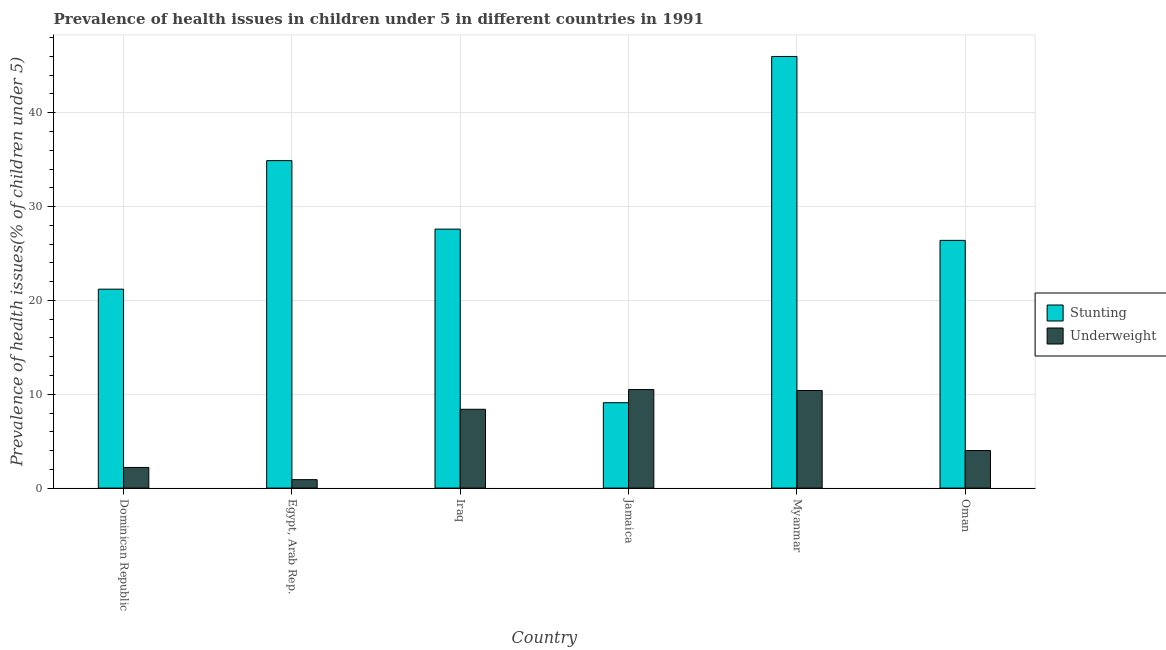How many groups of bars are there?
Make the answer very short. 6. What is the label of the 6th group of bars from the left?
Keep it short and to the point. Oman. What is the percentage of underweight children in Jamaica?
Offer a terse response. 10.5. Across all countries, what is the minimum percentage of stunted children?
Make the answer very short. 9.1. In which country was the percentage of stunted children maximum?
Provide a succinct answer. Myanmar. In which country was the percentage of stunted children minimum?
Provide a short and direct response. Jamaica. What is the total percentage of stunted children in the graph?
Offer a terse response. 165.2. What is the difference between the percentage of stunted children in Jamaica and that in Oman?
Ensure brevity in your answer.  -17.3. What is the difference between the percentage of underweight children in Oman and the percentage of stunted children in Jamaica?
Ensure brevity in your answer.  -5.1. What is the average percentage of stunted children per country?
Your response must be concise. 27.53. What is the difference between the percentage of underweight children and percentage of stunted children in Myanmar?
Ensure brevity in your answer.  -35.6. In how many countries, is the percentage of stunted children greater than 28 %?
Ensure brevity in your answer.  2. What is the ratio of the percentage of underweight children in Iraq to that in Oman?
Your answer should be very brief. 2.1. Is the percentage of stunted children in Jamaica less than that in Myanmar?
Provide a short and direct response. Yes. Is the difference between the percentage of underweight children in Dominican Republic and Jamaica greater than the difference between the percentage of stunted children in Dominican Republic and Jamaica?
Keep it short and to the point. No. What is the difference between the highest and the second highest percentage of stunted children?
Provide a succinct answer. 11.1. What is the difference between the highest and the lowest percentage of stunted children?
Ensure brevity in your answer.  36.9. Is the sum of the percentage of stunted children in Egypt, Arab Rep. and Myanmar greater than the maximum percentage of underweight children across all countries?
Make the answer very short. Yes. What does the 1st bar from the left in Jamaica represents?
Keep it short and to the point. Stunting. What does the 1st bar from the right in Jamaica represents?
Provide a short and direct response. Underweight. How many bars are there?
Make the answer very short. 12. How many countries are there in the graph?
Your response must be concise. 6. Are the values on the major ticks of Y-axis written in scientific E-notation?
Your response must be concise. No. Does the graph contain any zero values?
Your answer should be very brief. No. How are the legend labels stacked?
Your answer should be compact. Vertical. What is the title of the graph?
Keep it short and to the point. Prevalence of health issues in children under 5 in different countries in 1991. What is the label or title of the Y-axis?
Offer a terse response. Prevalence of health issues(% of children under 5). What is the Prevalence of health issues(% of children under 5) in Stunting in Dominican Republic?
Keep it short and to the point. 21.2. What is the Prevalence of health issues(% of children under 5) of Underweight in Dominican Republic?
Offer a terse response. 2.2. What is the Prevalence of health issues(% of children under 5) in Stunting in Egypt, Arab Rep.?
Your response must be concise. 34.9. What is the Prevalence of health issues(% of children under 5) of Underweight in Egypt, Arab Rep.?
Make the answer very short. 0.9. What is the Prevalence of health issues(% of children under 5) of Stunting in Iraq?
Your answer should be very brief. 27.6. What is the Prevalence of health issues(% of children under 5) in Underweight in Iraq?
Your answer should be very brief. 8.4. What is the Prevalence of health issues(% of children under 5) in Stunting in Jamaica?
Give a very brief answer. 9.1. What is the Prevalence of health issues(% of children under 5) of Underweight in Jamaica?
Make the answer very short. 10.5. What is the Prevalence of health issues(% of children under 5) of Stunting in Myanmar?
Offer a very short reply. 46. What is the Prevalence of health issues(% of children under 5) in Underweight in Myanmar?
Offer a very short reply. 10.4. What is the Prevalence of health issues(% of children under 5) of Stunting in Oman?
Keep it short and to the point. 26.4. Across all countries, what is the maximum Prevalence of health issues(% of children under 5) in Underweight?
Offer a very short reply. 10.5. Across all countries, what is the minimum Prevalence of health issues(% of children under 5) in Stunting?
Provide a succinct answer. 9.1. Across all countries, what is the minimum Prevalence of health issues(% of children under 5) of Underweight?
Ensure brevity in your answer.  0.9. What is the total Prevalence of health issues(% of children under 5) in Stunting in the graph?
Your answer should be very brief. 165.2. What is the total Prevalence of health issues(% of children under 5) in Underweight in the graph?
Your answer should be very brief. 36.4. What is the difference between the Prevalence of health issues(% of children under 5) of Stunting in Dominican Republic and that in Egypt, Arab Rep.?
Your answer should be compact. -13.7. What is the difference between the Prevalence of health issues(% of children under 5) of Underweight in Dominican Republic and that in Egypt, Arab Rep.?
Keep it short and to the point. 1.3. What is the difference between the Prevalence of health issues(% of children under 5) in Stunting in Dominican Republic and that in Iraq?
Offer a terse response. -6.4. What is the difference between the Prevalence of health issues(% of children under 5) of Underweight in Dominican Republic and that in Jamaica?
Offer a terse response. -8.3. What is the difference between the Prevalence of health issues(% of children under 5) of Stunting in Dominican Republic and that in Myanmar?
Provide a succinct answer. -24.8. What is the difference between the Prevalence of health issues(% of children under 5) in Underweight in Dominican Republic and that in Myanmar?
Provide a short and direct response. -8.2. What is the difference between the Prevalence of health issues(% of children under 5) in Stunting in Dominican Republic and that in Oman?
Offer a terse response. -5.2. What is the difference between the Prevalence of health issues(% of children under 5) of Underweight in Dominican Republic and that in Oman?
Make the answer very short. -1.8. What is the difference between the Prevalence of health issues(% of children under 5) in Underweight in Egypt, Arab Rep. and that in Iraq?
Give a very brief answer. -7.5. What is the difference between the Prevalence of health issues(% of children under 5) of Stunting in Egypt, Arab Rep. and that in Jamaica?
Provide a succinct answer. 25.8. What is the difference between the Prevalence of health issues(% of children under 5) in Underweight in Egypt, Arab Rep. and that in Jamaica?
Your answer should be very brief. -9.6. What is the difference between the Prevalence of health issues(% of children under 5) in Stunting in Egypt, Arab Rep. and that in Myanmar?
Provide a succinct answer. -11.1. What is the difference between the Prevalence of health issues(% of children under 5) of Stunting in Iraq and that in Jamaica?
Your answer should be very brief. 18.5. What is the difference between the Prevalence of health issues(% of children under 5) of Underweight in Iraq and that in Jamaica?
Your answer should be very brief. -2.1. What is the difference between the Prevalence of health issues(% of children under 5) in Stunting in Iraq and that in Myanmar?
Keep it short and to the point. -18.4. What is the difference between the Prevalence of health issues(% of children under 5) in Stunting in Iraq and that in Oman?
Make the answer very short. 1.2. What is the difference between the Prevalence of health issues(% of children under 5) in Underweight in Iraq and that in Oman?
Keep it short and to the point. 4.4. What is the difference between the Prevalence of health issues(% of children under 5) of Stunting in Jamaica and that in Myanmar?
Offer a very short reply. -36.9. What is the difference between the Prevalence of health issues(% of children under 5) of Stunting in Jamaica and that in Oman?
Offer a very short reply. -17.3. What is the difference between the Prevalence of health issues(% of children under 5) of Underweight in Jamaica and that in Oman?
Give a very brief answer. 6.5. What is the difference between the Prevalence of health issues(% of children under 5) in Stunting in Myanmar and that in Oman?
Make the answer very short. 19.6. What is the difference between the Prevalence of health issues(% of children under 5) of Stunting in Dominican Republic and the Prevalence of health issues(% of children under 5) of Underweight in Egypt, Arab Rep.?
Ensure brevity in your answer.  20.3. What is the difference between the Prevalence of health issues(% of children under 5) in Stunting in Dominican Republic and the Prevalence of health issues(% of children under 5) in Underweight in Jamaica?
Offer a terse response. 10.7. What is the difference between the Prevalence of health issues(% of children under 5) of Stunting in Dominican Republic and the Prevalence of health issues(% of children under 5) of Underweight in Myanmar?
Keep it short and to the point. 10.8. What is the difference between the Prevalence of health issues(% of children under 5) in Stunting in Dominican Republic and the Prevalence of health issues(% of children under 5) in Underweight in Oman?
Keep it short and to the point. 17.2. What is the difference between the Prevalence of health issues(% of children under 5) of Stunting in Egypt, Arab Rep. and the Prevalence of health issues(% of children under 5) of Underweight in Jamaica?
Make the answer very short. 24.4. What is the difference between the Prevalence of health issues(% of children under 5) in Stunting in Egypt, Arab Rep. and the Prevalence of health issues(% of children under 5) in Underweight in Oman?
Provide a short and direct response. 30.9. What is the difference between the Prevalence of health issues(% of children under 5) of Stunting in Iraq and the Prevalence of health issues(% of children under 5) of Underweight in Myanmar?
Provide a succinct answer. 17.2. What is the difference between the Prevalence of health issues(% of children under 5) of Stunting in Iraq and the Prevalence of health issues(% of children under 5) of Underweight in Oman?
Make the answer very short. 23.6. What is the difference between the Prevalence of health issues(% of children under 5) in Stunting in Jamaica and the Prevalence of health issues(% of children under 5) in Underweight in Myanmar?
Offer a terse response. -1.3. What is the average Prevalence of health issues(% of children under 5) in Stunting per country?
Provide a succinct answer. 27.53. What is the average Prevalence of health issues(% of children under 5) in Underweight per country?
Offer a very short reply. 6.07. What is the difference between the Prevalence of health issues(% of children under 5) of Stunting and Prevalence of health issues(% of children under 5) of Underweight in Egypt, Arab Rep.?
Your answer should be very brief. 34. What is the difference between the Prevalence of health issues(% of children under 5) of Stunting and Prevalence of health issues(% of children under 5) of Underweight in Iraq?
Offer a terse response. 19.2. What is the difference between the Prevalence of health issues(% of children under 5) of Stunting and Prevalence of health issues(% of children under 5) of Underweight in Myanmar?
Keep it short and to the point. 35.6. What is the difference between the Prevalence of health issues(% of children under 5) of Stunting and Prevalence of health issues(% of children under 5) of Underweight in Oman?
Ensure brevity in your answer.  22.4. What is the ratio of the Prevalence of health issues(% of children under 5) of Stunting in Dominican Republic to that in Egypt, Arab Rep.?
Your response must be concise. 0.61. What is the ratio of the Prevalence of health issues(% of children under 5) in Underweight in Dominican Republic to that in Egypt, Arab Rep.?
Make the answer very short. 2.44. What is the ratio of the Prevalence of health issues(% of children under 5) of Stunting in Dominican Republic to that in Iraq?
Ensure brevity in your answer.  0.77. What is the ratio of the Prevalence of health issues(% of children under 5) in Underweight in Dominican Republic to that in Iraq?
Provide a succinct answer. 0.26. What is the ratio of the Prevalence of health issues(% of children under 5) in Stunting in Dominican Republic to that in Jamaica?
Make the answer very short. 2.33. What is the ratio of the Prevalence of health issues(% of children under 5) of Underweight in Dominican Republic to that in Jamaica?
Ensure brevity in your answer.  0.21. What is the ratio of the Prevalence of health issues(% of children under 5) in Stunting in Dominican Republic to that in Myanmar?
Offer a very short reply. 0.46. What is the ratio of the Prevalence of health issues(% of children under 5) of Underweight in Dominican Republic to that in Myanmar?
Ensure brevity in your answer.  0.21. What is the ratio of the Prevalence of health issues(% of children under 5) in Stunting in Dominican Republic to that in Oman?
Offer a very short reply. 0.8. What is the ratio of the Prevalence of health issues(% of children under 5) in Underweight in Dominican Republic to that in Oman?
Ensure brevity in your answer.  0.55. What is the ratio of the Prevalence of health issues(% of children under 5) in Stunting in Egypt, Arab Rep. to that in Iraq?
Your response must be concise. 1.26. What is the ratio of the Prevalence of health issues(% of children under 5) of Underweight in Egypt, Arab Rep. to that in Iraq?
Make the answer very short. 0.11. What is the ratio of the Prevalence of health issues(% of children under 5) in Stunting in Egypt, Arab Rep. to that in Jamaica?
Give a very brief answer. 3.84. What is the ratio of the Prevalence of health issues(% of children under 5) of Underweight in Egypt, Arab Rep. to that in Jamaica?
Your response must be concise. 0.09. What is the ratio of the Prevalence of health issues(% of children under 5) of Stunting in Egypt, Arab Rep. to that in Myanmar?
Your answer should be very brief. 0.76. What is the ratio of the Prevalence of health issues(% of children under 5) in Underweight in Egypt, Arab Rep. to that in Myanmar?
Your answer should be compact. 0.09. What is the ratio of the Prevalence of health issues(% of children under 5) of Stunting in Egypt, Arab Rep. to that in Oman?
Ensure brevity in your answer.  1.32. What is the ratio of the Prevalence of health issues(% of children under 5) of Underweight in Egypt, Arab Rep. to that in Oman?
Offer a terse response. 0.23. What is the ratio of the Prevalence of health issues(% of children under 5) in Stunting in Iraq to that in Jamaica?
Offer a very short reply. 3.03. What is the ratio of the Prevalence of health issues(% of children under 5) in Underweight in Iraq to that in Jamaica?
Provide a succinct answer. 0.8. What is the ratio of the Prevalence of health issues(% of children under 5) of Underweight in Iraq to that in Myanmar?
Keep it short and to the point. 0.81. What is the ratio of the Prevalence of health issues(% of children under 5) of Stunting in Iraq to that in Oman?
Offer a terse response. 1.05. What is the ratio of the Prevalence of health issues(% of children under 5) of Underweight in Iraq to that in Oman?
Keep it short and to the point. 2.1. What is the ratio of the Prevalence of health issues(% of children under 5) in Stunting in Jamaica to that in Myanmar?
Your answer should be very brief. 0.2. What is the ratio of the Prevalence of health issues(% of children under 5) in Underweight in Jamaica to that in Myanmar?
Keep it short and to the point. 1.01. What is the ratio of the Prevalence of health issues(% of children under 5) in Stunting in Jamaica to that in Oman?
Your answer should be compact. 0.34. What is the ratio of the Prevalence of health issues(% of children under 5) in Underweight in Jamaica to that in Oman?
Your answer should be compact. 2.62. What is the ratio of the Prevalence of health issues(% of children under 5) of Stunting in Myanmar to that in Oman?
Provide a succinct answer. 1.74. What is the difference between the highest and the second highest Prevalence of health issues(% of children under 5) in Stunting?
Offer a terse response. 11.1. What is the difference between the highest and the second highest Prevalence of health issues(% of children under 5) of Underweight?
Your answer should be very brief. 0.1. What is the difference between the highest and the lowest Prevalence of health issues(% of children under 5) of Stunting?
Your answer should be compact. 36.9. What is the difference between the highest and the lowest Prevalence of health issues(% of children under 5) of Underweight?
Provide a short and direct response. 9.6. 